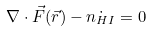<formula> <loc_0><loc_0><loc_500><loc_500>\nabla \cdot \vec { F } ( \vec { r } ) - \dot { n _ { H I } } = 0</formula> 